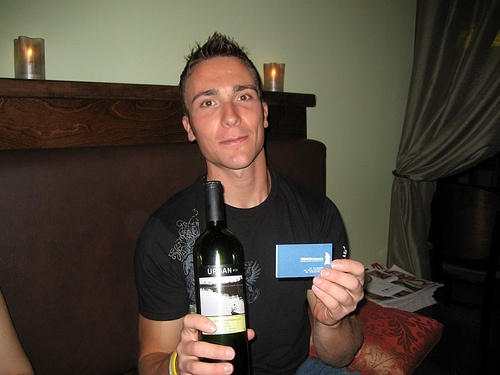Describe the objects in this image and their specific colors. I can see people in gray, black, brown, and salmon tones, bottle in gray, black, white, and khaki tones, and people in gray, brown, black, and maroon tones in this image. 